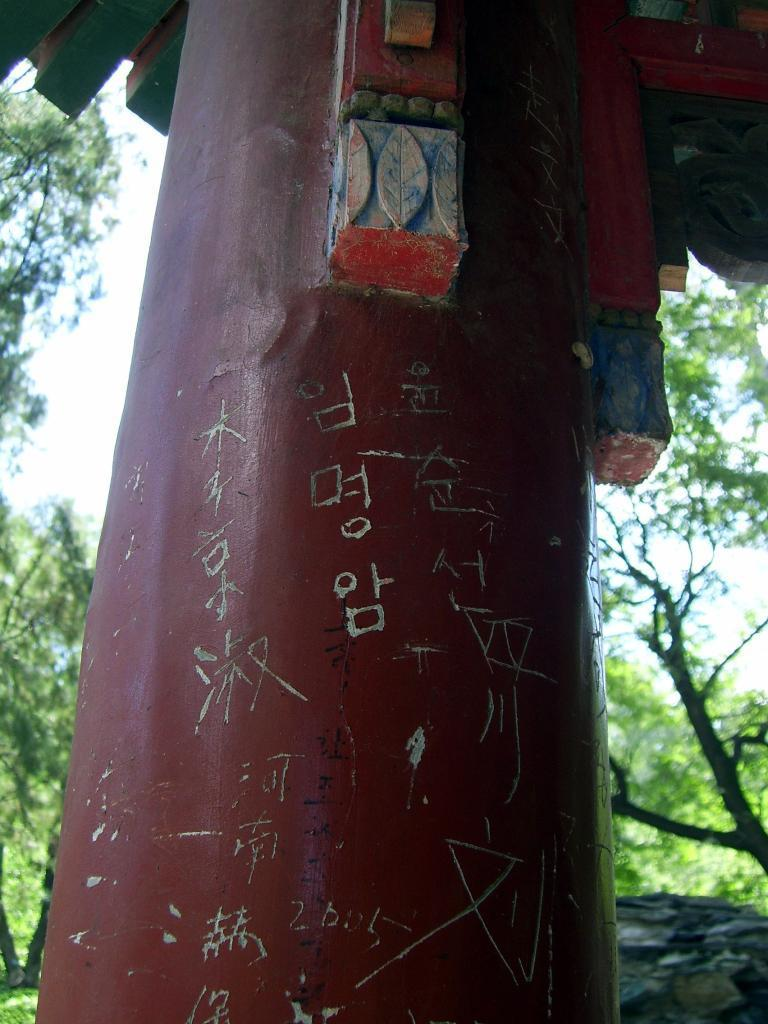What is the main structure in the image? There is a pillar in the image. What can be seen behind the pillar? There are trees visible behind the pillar. What part of the natural environment is visible in the image? The sky is visible in the image. What type of liquid can be seen flowing from the bone in the image? There is no bone or liquid present in the image; it only features a pillar and trees in the background. 